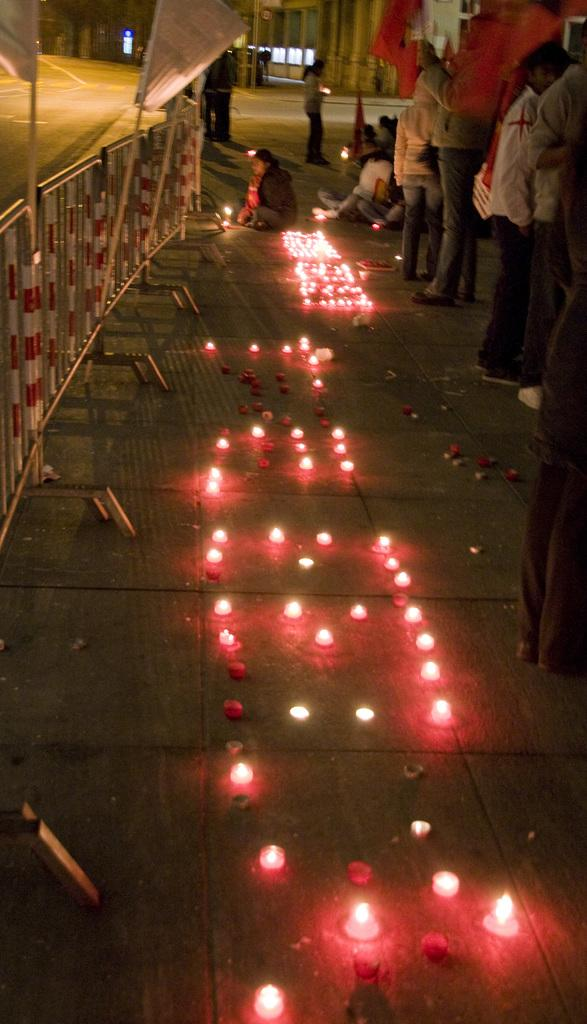What is located on the ground in the image? There are lights on the ground in the image. What can be seen on the left side of the image? There is a fence on the left side of the image. What is happening on the right side of the image? There are people standing on the right side of the image. What type of stitch is being used to sew the ground in the image? There is no stitching or sewing present in the image; it features lights on the ground, a fence on the left side, and people standing on the right side. Can you tell me how many fowl are visible in the image? There are no fowl present in the image. 